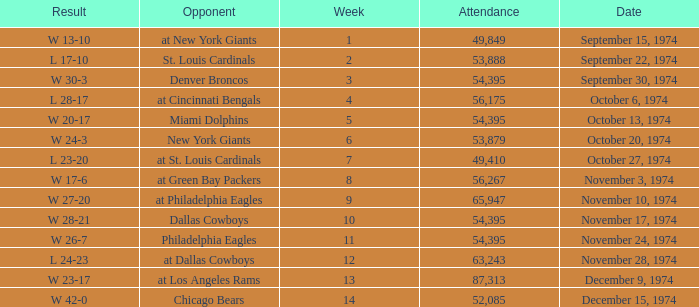Can you parse all the data within this table? {'header': ['Result', 'Opponent', 'Week', 'Attendance', 'Date'], 'rows': [['W 13-10', 'at New York Giants', '1', '49,849', 'September 15, 1974'], ['L 17-10', 'St. Louis Cardinals', '2', '53,888', 'September 22, 1974'], ['W 30-3', 'Denver Broncos', '3', '54,395', 'September 30, 1974'], ['L 28-17', 'at Cincinnati Bengals', '4', '56,175', 'October 6, 1974'], ['W 20-17', 'Miami Dolphins', '5', '54,395', 'October 13, 1974'], ['W 24-3', 'New York Giants', '6', '53,879', 'October 20, 1974'], ['L 23-20', 'at St. Louis Cardinals', '7', '49,410', 'October 27, 1974'], ['W 17-6', 'at Green Bay Packers', '8', '56,267', 'November 3, 1974'], ['W 27-20', 'at Philadelphia Eagles', '9', '65,947', 'November 10, 1974'], ['W 28-21', 'Dallas Cowboys', '10', '54,395', 'November 17, 1974'], ['W 26-7', 'Philadelphia Eagles', '11', '54,395', 'November 24, 1974'], ['L 24-23', 'at Dallas Cowboys', '12', '63,243', 'November 28, 1974'], ['W 23-17', 'at Los Angeles Rams', '13', '87,313', 'December 9, 1974'], ['W 42-0', 'Chicago Bears', '14', '52,085', 'December 15, 1974']]} What is the week of the game played on November 28, 1974? 12.0. 